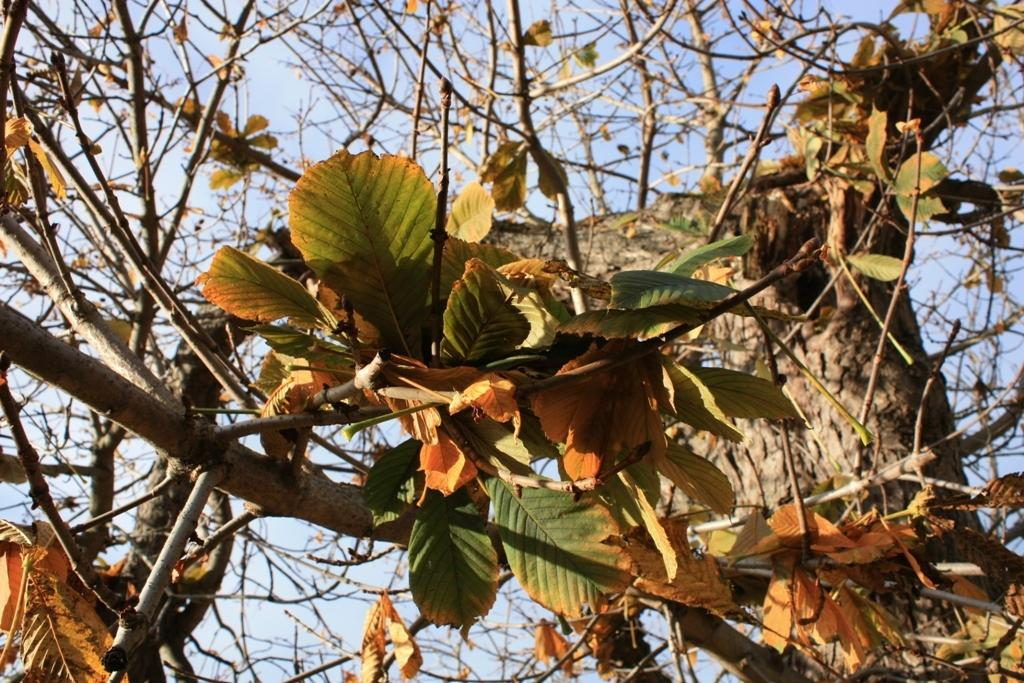What type of plant can be seen in the image? There is a tree in the image. What features of the tree are visible? The tree has branches and leaves. What can be seen in the background of the image? There is a sky visible in the background of the image. What type of ice can be seen melting on the branches of the tree in the image? There is no ice present on the tree in the image. 